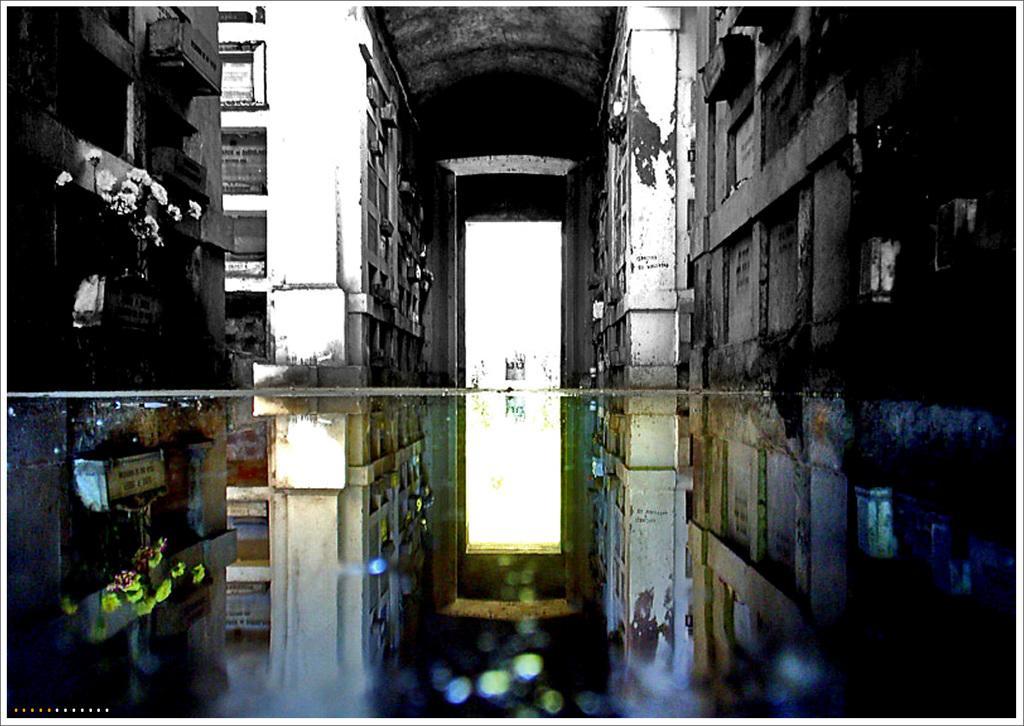Please provide a concise description of this image. In this picture we can see water, buildings with windows, flowers, arch and some objects. 